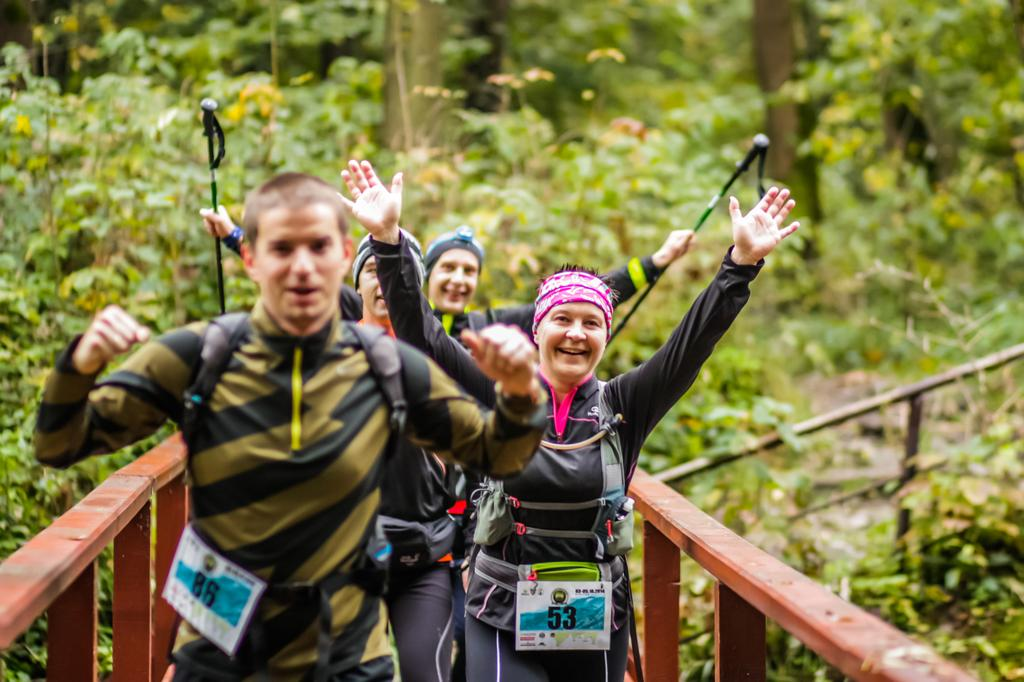How many people are in the image? There are four persons in the image. What are the people wearing in the image? Each person is wearing a bag. What can be seen on the left side of the image? There is a brown-colored railing on the left side of the image. What can be seen on the right side of the image? There is a brown-colored railing on the right side of the image. What type of skate is being used by the person on the right side of the image? There is no skate present in the image; the people are wearing bags and standing near railings. What type of vest is being worn by the person on the left side of the image? There is no vest mentioned or visible in the image; the people are wearing bags. 